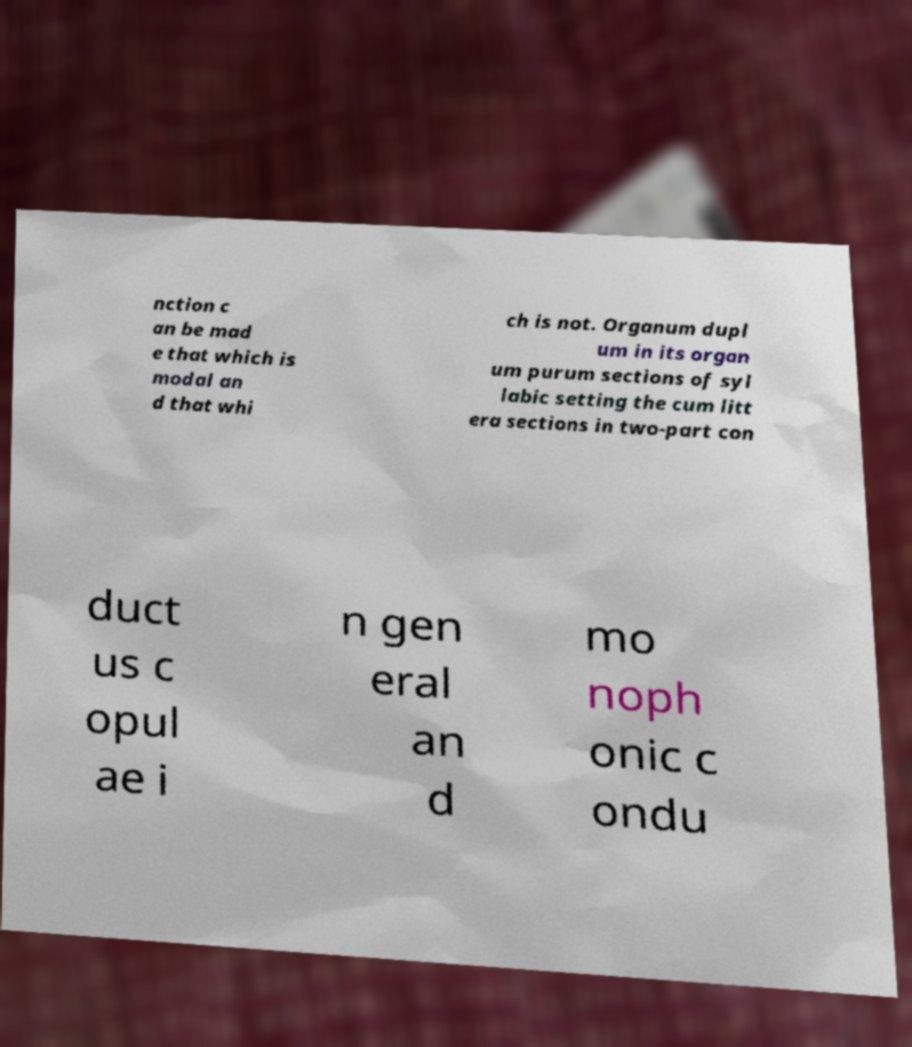Could you assist in decoding the text presented in this image and type it out clearly? nction c an be mad e that which is modal an d that whi ch is not. Organum dupl um in its organ um purum sections of syl labic setting the cum litt era sections in two-part con duct us c opul ae i n gen eral an d mo noph onic c ondu 